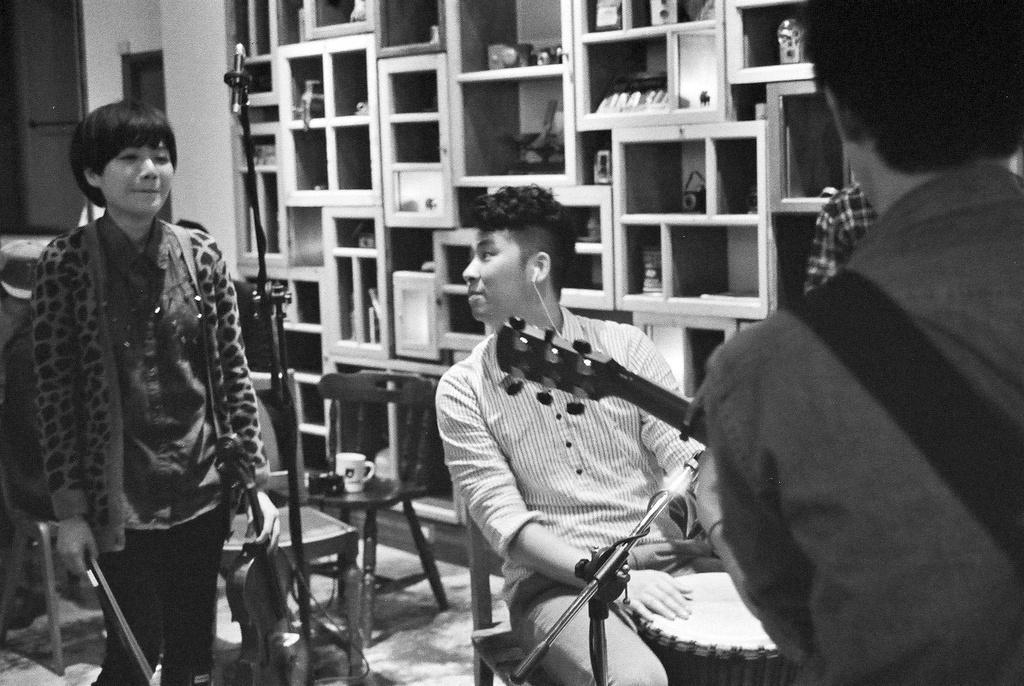Please provide a concise description of this image. In this image, we can see a person wearing clothes and standing beside the mic. This person is holding a violin and stick with her hands. There is a person at the bottom of the image sitting on the chair and playing drums in front of the mic. There is an another person on the right side of the image wearing a guitar. There are chairs and cupboards in the middle of the image. 